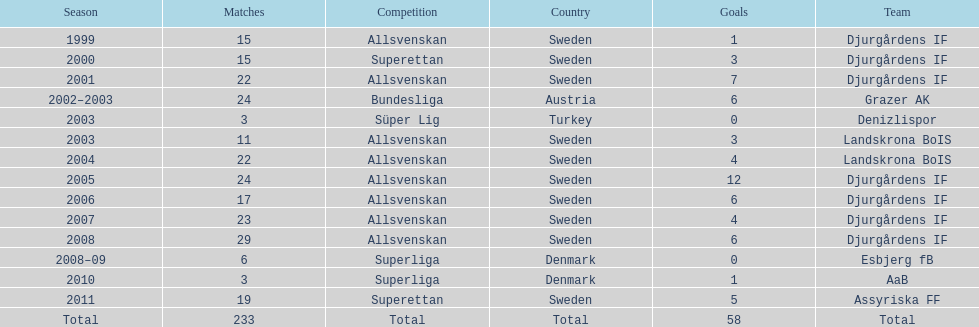What is the total number of goals scored by jones kusi-asare? 58. 